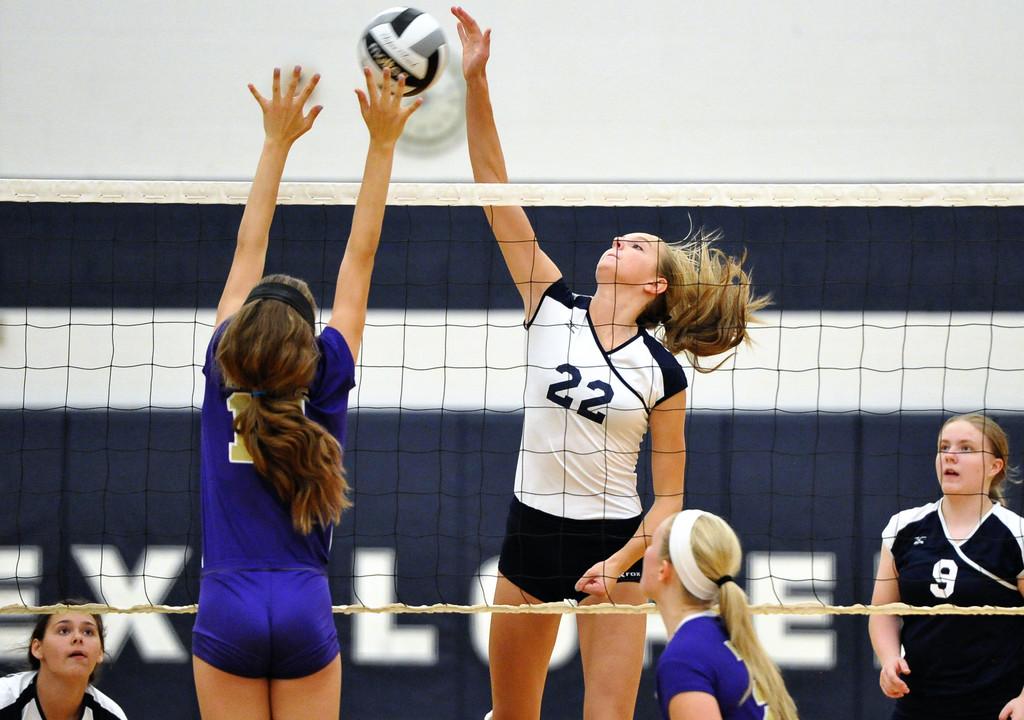What is the jersey number of the girl in white?
Offer a very short reply. 22. 